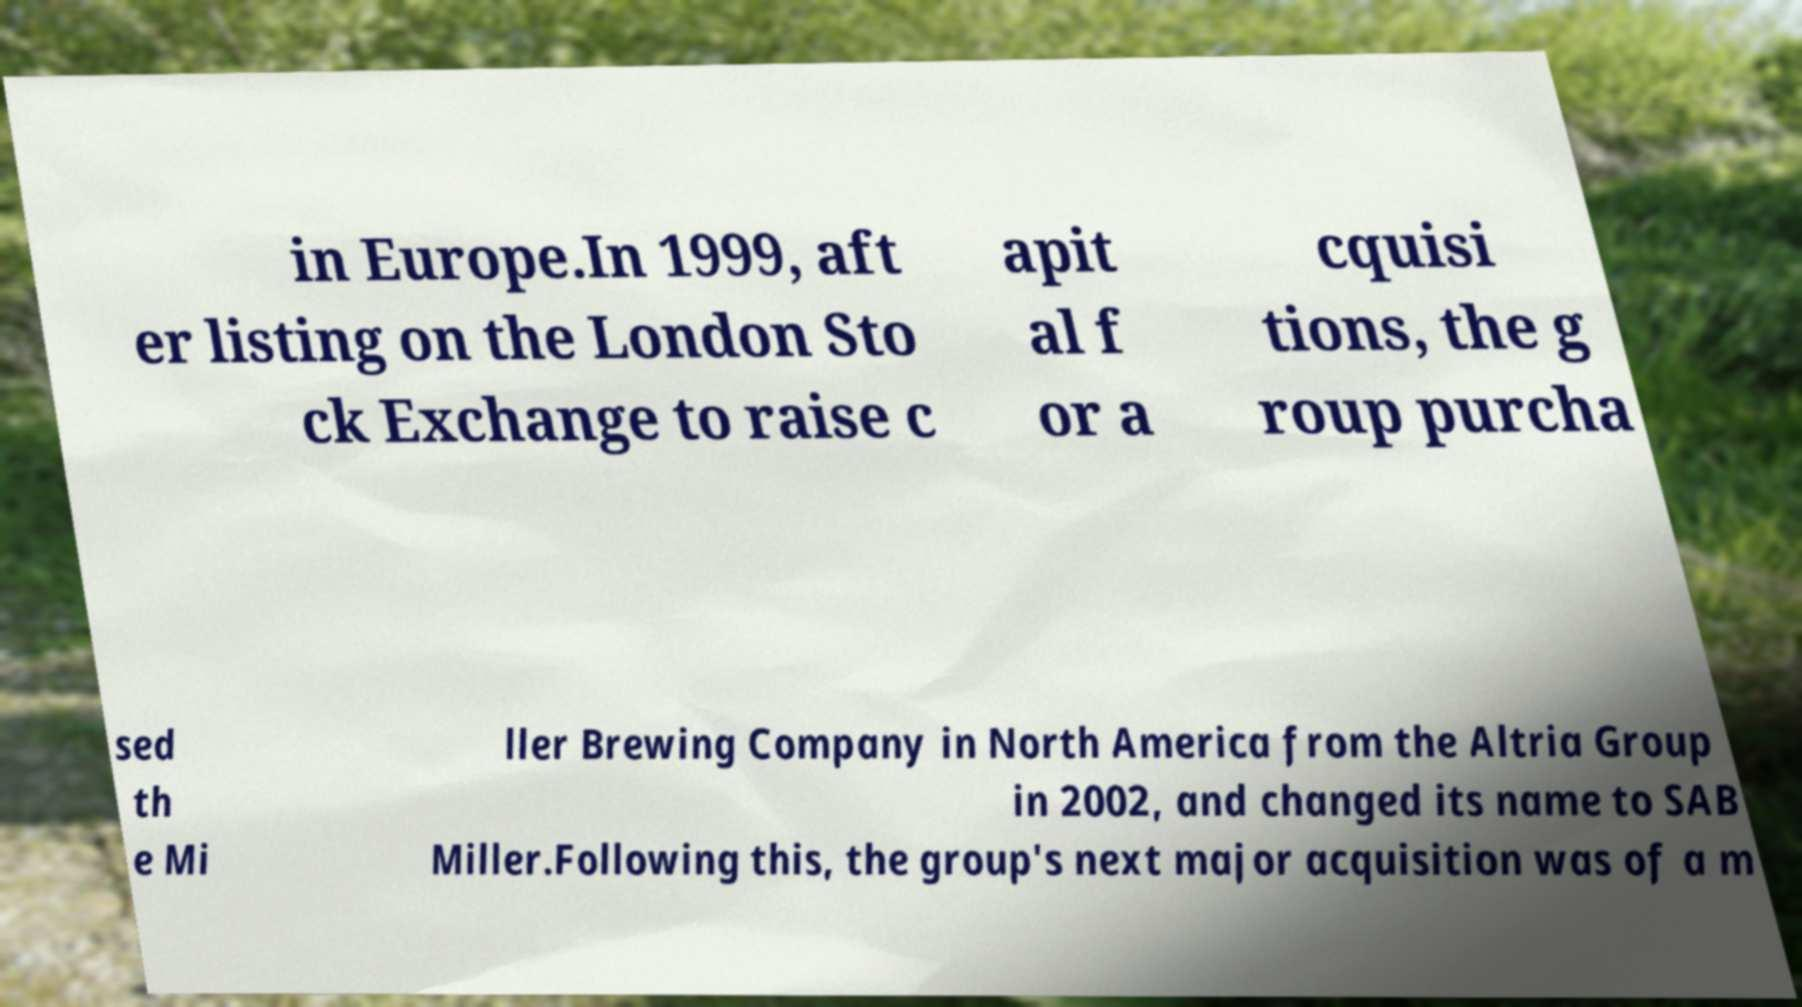Can you accurately transcribe the text from the provided image for me? in Europe.In 1999, aft er listing on the London Sto ck Exchange to raise c apit al f or a cquisi tions, the g roup purcha sed th e Mi ller Brewing Company in North America from the Altria Group in 2002, and changed its name to SAB Miller.Following this, the group's next major acquisition was of a m 